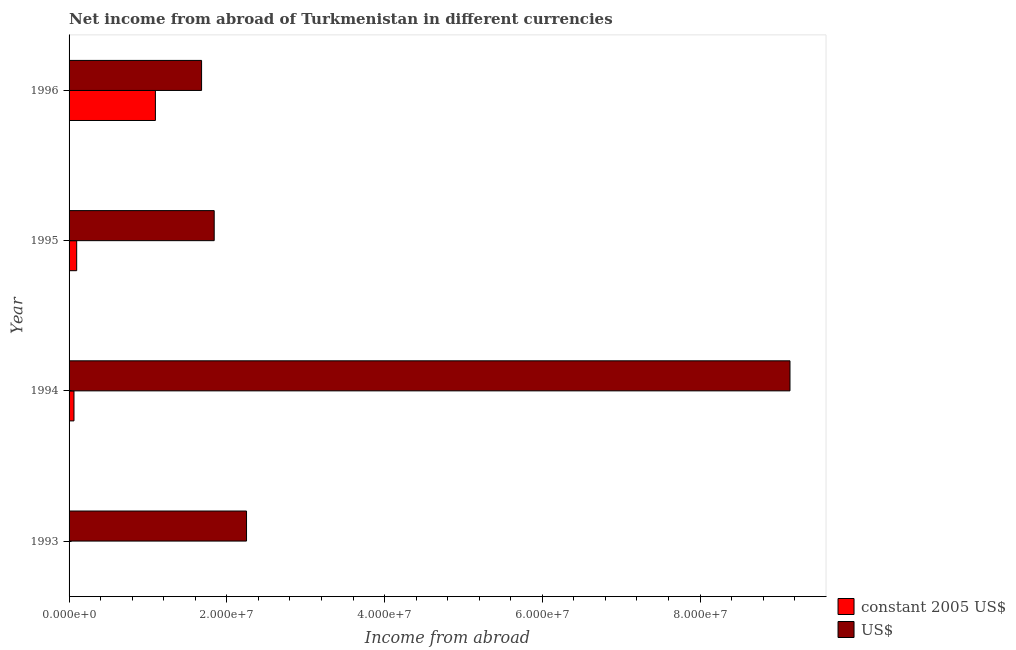How many groups of bars are there?
Make the answer very short. 4. Are the number of bars on each tick of the Y-axis equal?
Keep it short and to the point. Yes. How many bars are there on the 1st tick from the bottom?
Ensure brevity in your answer.  2. What is the income from abroad in us$ in 1994?
Your response must be concise. 9.14e+07. Across all years, what is the maximum income from abroad in constant 2005 us$?
Make the answer very short. 1.09e+07. Across all years, what is the minimum income from abroad in us$?
Make the answer very short. 1.68e+07. In which year was the income from abroad in constant 2005 us$ minimum?
Your response must be concise. 1993. What is the total income from abroad in us$ in the graph?
Offer a very short reply. 1.49e+08. What is the difference between the income from abroad in us$ in 1995 and that in 1996?
Your answer should be very brief. 1.60e+06. What is the difference between the income from abroad in constant 2005 us$ in 1995 and the income from abroad in us$ in 1994?
Provide a short and direct response. -9.04e+07. What is the average income from abroad in constant 2005 us$ per year?
Make the answer very short. 3.14e+06. In the year 1995, what is the difference between the income from abroad in us$ and income from abroad in constant 2005 us$?
Provide a short and direct response. 1.74e+07. In how many years, is the income from abroad in us$ greater than 4000000 units?
Provide a succinct answer. 4. What is the difference between the highest and the second highest income from abroad in us$?
Provide a short and direct response. 6.89e+07. What is the difference between the highest and the lowest income from abroad in constant 2005 us$?
Provide a short and direct response. 1.09e+07. In how many years, is the income from abroad in us$ greater than the average income from abroad in us$ taken over all years?
Offer a very short reply. 1. Is the sum of the income from abroad in us$ in 1995 and 1996 greater than the maximum income from abroad in constant 2005 us$ across all years?
Keep it short and to the point. Yes. What does the 1st bar from the top in 1995 represents?
Make the answer very short. US$. What does the 1st bar from the bottom in 1993 represents?
Your answer should be very brief. Constant 2005 us$. How many bars are there?
Ensure brevity in your answer.  8. Are all the bars in the graph horizontal?
Your answer should be compact. Yes. Where does the legend appear in the graph?
Make the answer very short. Bottom right. How many legend labels are there?
Give a very brief answer. 2. What is the title of the graph?
Offer a terse response. Net income from abroad of Turkmenistan in different currencies. What is the label or title of the X-axis?
Your answer should be very brief. Income from abroad. What is the Income from abroad of constant 2005 US$ in 1993?
Your answer should be compact. 1.42e+04. What is the Income from abroad in US$ in 1993?
Make the answer very short. 2.25e+07. What is the Income from abroad of constant 2005 US$ in 1994?
Give a very brief answer. 6.22e+05. What is the Income from abroad in US$ in 1994?
Provide a succinct answer. 9.14e+07. What is the Income from abroad of constant 2005 US$ in 1995?
Keep it short and to the point. 9.67e+05. What is the Income from abroad in US$ in 1995?
Give a very brief answer. 1.84e+07. What is the Income from abroad in constant 2005 US$ in 1996?
Give a very brief answer. 1.09e+07. What is the Income from abroad of US$ in 1996?
Provide a succinct answer. 1.68e+07. Across all years, what is the maximum Income from abroad in constant 2005 US$?
Make the answer very short. 1.09e+07. Across all years, what is the maximum Income from abroad in US$?
Provide a short and direct response. 9.14e+07. Across all years, what is the minimum Income from abroad in constant 2005 US$?
Offer a very short reply. 1.42e+04. Across all years, what is the minimum Income from abroad of US$?
Make the answer very short. 1.68e+07. What is the total Income from abroad in constant 2005 US$ in the graph?
Ensure brevity in your answer.  1.26e+07. What is the total Income from abroad of US$ in the graph?
Make the answer very short. 1.49e+08. What is the difference between the Income from abroad of constant 2005 US$ in 1993 and that in 1994?
Provide a succinct answer. -6.08e+05. What is the difference between the Income from abroad in US$ in 1993 and that in 1994?
Your answer should be very brief. -6.89e+07. What is the difference between the Income from abroad in constant 2005 US$ in 1993 and that in 1995?
Your answer should be compact. -9.52e+05. What is the difference between the Income from abroad of US$ in 1993 and that in 1995?
Make the answer very short. 4.10e+06. What is the difference between the Income from abroad of constant 2005 US$ in 1993 and that in 1996?
Ensure brevity in your answer.  -1.09e+07. What is the difference between the Income from abroad of US$ in 1993 and that in 1996?
Your response must be concise. 5.70e+06. What is the difference between the Income from abroad of constant 2005 US$ in 1994 and that in 1995?
Your response must be concise. -3.44e+05. What is the difference between the Income from abroad in US$ in 1994 and that in 1995?
Your response must be concise. 7.30e+07. What is the difference between the Income from abroad in constant 2005 US$ in 1994 and that in 1996?
Keep it short and to the point. -1.03e+07. What is the difference between the Income from abroad in US$ in 1994 and that in 1996?
Keep it short and to the point. 7.46e+07. What is the difference between the Income from abroad of constant 2005 US$ in 1995 and that in 1996?
Provide a succinct answer. -9.98e+06. What is the difference between the Income from abroad in US$ in 1995 and that in 1996?
Offer a terse response. 1.60e+06. What is the difference between the Income from abroad of constant 2005 US$ in 1993 and the Income from abroad of US$ in 1994?
Provide a succinct answer. -9.14e+07. What is the difference between the Income from abroad in constant 2005 US$ in 1993 and the Income from abroad in US$ in 1995?
Provide a succinct answer. -1.84e+07. What is the difference between the Income from abroad in constant 2005 US$ in 1993 and the Income from abroad in US$ in 1996?
Your response must be concise. -1.68e+07. What is the difference between the Income from abroad of constant 2005 US$ in 1994 and the Income from abroad of US$ in 1995?
Provide a succinct answer. -1.78e+07. What is the difference between the Income from abroad of constant 2005 US$ in 1994 and the Income from abroad of US$ in 1996?
Your answer should be very brief. -1.62e+07. What is the difference between the Income from abroad of constant 2005 US$ in 1995 and the Income from abroad of US$ in 1996?
Offer a very short reply. -1.58e+07. What is the average Income from abroad of constant 2005 US$ per year?
Your answer should be compact. 3.14e+06. What is the average Income from abroad in US$ per year?
Make the answer very short. 3.73e+07. In the year 1993, what is the difference between the Income from abroad of constant 2005 US$ and Income from abroad of US$?
Make the answer very short. -2.25e+07. In the year 1994, what is the difference between the Income from abroad of constant 2005 US$ and Income from abroad of US$?
Provide a short and direct response. -9.08e+07. In the year 1995, what is the difference between the Income from abroad of constant 2005 US$ and Income from abroad of US$?
Ensure brevity in your answer.  -1.74e+07. In the year 1996, what is the difference between the Income from abroad of constant 2005 US$ and Income from abroad of US$?
Your answer should be very brief. -5.85e+06. What is the ratio of the Income from abroad of constant 2005 US$ in 1993 to that in 1994?
Make the answer very short. 0.02. What is the ratio of the Income from abroad of US$ in 1993 to that in 1994?
Provide a short and direct response. 0.25. What is the ratio of the Income from abroad of constant 2005 US$ in 1993 to that in 1995?
Your answer should be compact. 0.01. What is the ratio of the Income from abroad in US$ in 1993 to that in 1995?
Your answer should be compact. 1.22. What is the ratio of the Income from abroad of constant 2005 US$ in 1993 to that in 1996?
Provide a short and direct response. 0. What is the ratio of the Income from abroad in US$ in 1993 to that in 1996?
Keep it short and to the point. 1.34. What is the ratio of the Income from abroad in constant 2005 US$ in 1994 to that in 1995?
Your answer should be compact. 0.64. What is the ratio of the Income from abroad in US$ in 1994 to that in 1995?
Ensure brevity in your answer.  4.97. What is the ratio of the Income from abroad in constant 2005 US$ in 1994 to that in 1996?
Keep it short and to the point. 0.06. What is the ratio of the Income from abroad in US$ in 1994 to that in 1996?
Offer a terse response. 5.44. What is the ratio of the Income from abroad in constant 2005 US$ in 1995 to that in 1996?
Offer a very short reply. 0.09. What is the ratio of the Income from abroad in US$ in 1995 to that in 1996?
Keep it short and to the point. 1.1. What is the difference between the highest and the second highest Income from abroad of constant 2005 US$?
Offer a terse response. 9.98e+06. What is the difference between the highest and the second highest Income from abroad in US$?
Your answer should be compact. 6.89e+07. What is the difference between the highest and the lowest Income from abroad of constant 2005 US$?
Ensure brevity in your answer.  1.09e+07. What is the difference between the highest and the lowest Income from abroad of US$?
Your response must be concise. 7.46e+07. 